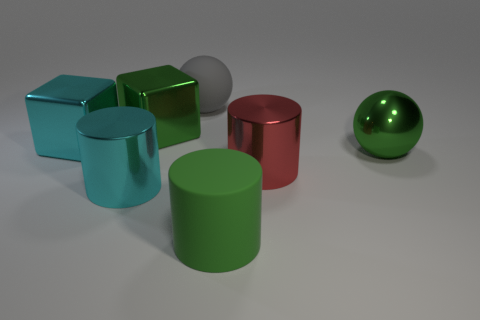Do the cylinder that is left of the big gray rubber sphere and the big cube right of the cyan cylinder have the same material?
Offer a terse response. Yes. How many objects are either large balls or green things left of the big gray rubber sphere?
Provide a short and direct response. 3. Is there anything else that has the same material as the large cyan cube?
Offer a very short reply. Yes. What shape is the shiny object that is the same color as the metal ball?
Your answer should be compact. Cube. What is the cyan block made of?
Offer a terse response. Metal. Are the big cyan cube and the green sphere made of the same material?
Your answer should be compact. Yes. How many matte objects are cyan cubes or purple balls?
Keep it short and to the point. 0. The large thing left of the large cyan cylinder has what shape?
Keep it short and to the point. Cube. What size is the cyan cylinder that is made of the same material as the green block?
Offer a terse response. Large. There is a big metallic object that is on the right side of the large cyan metal cylinder and to the left of the large green cylinder; what is its shape?
Provide a succinct answer. Cube. 